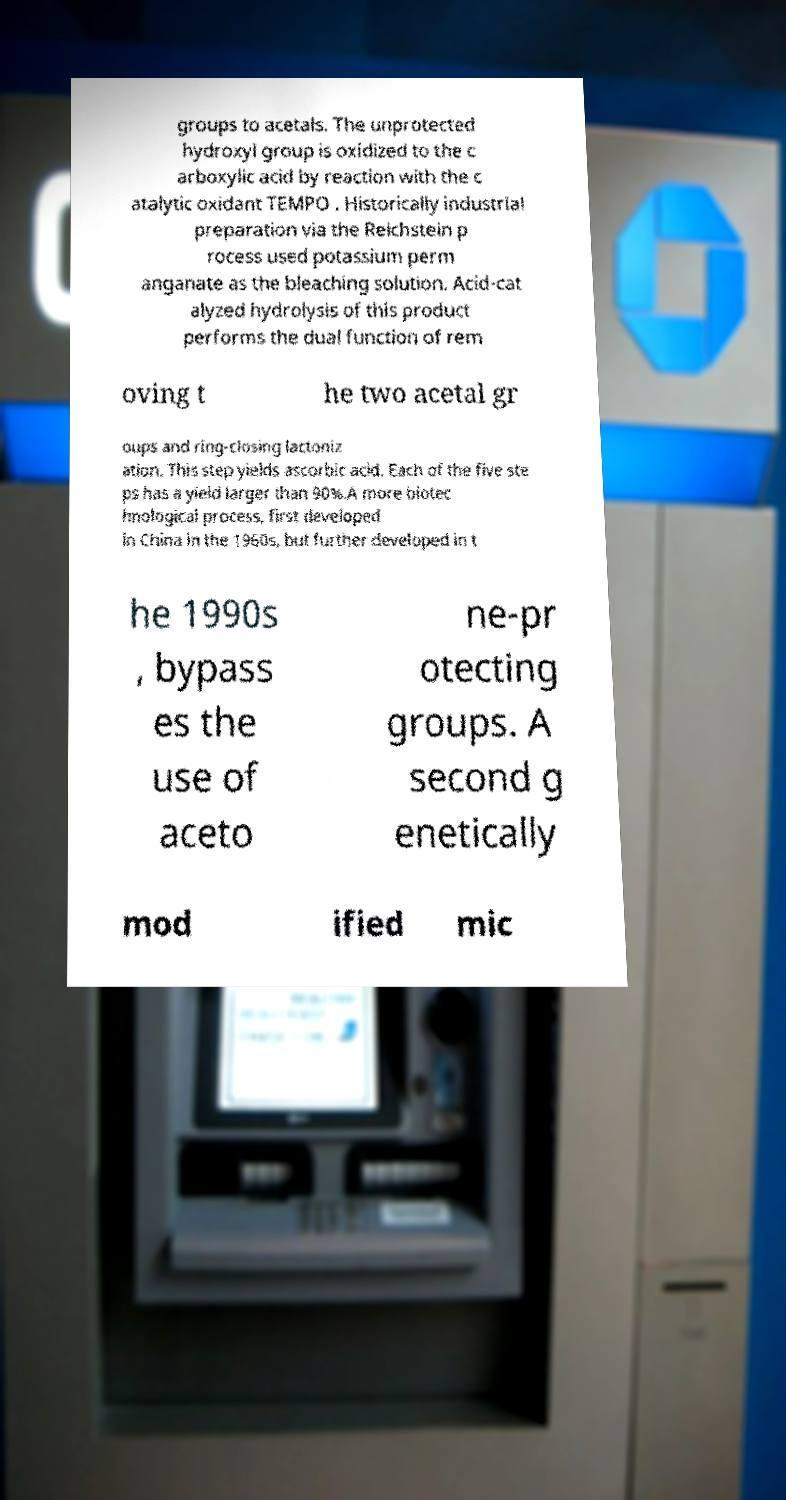Can you read and provide the text displayed in the image?This photo seems to have some interesting text. Can you extract and type it out for me? groups to acetals. The unprotected hydroxyl group is oxidized to the c arboxylic acid by reaction with the c atalytic oxidant TEMPO . Historically industrial preparation via the Reichstein p rocess used potassium perm anganate as the bleaching solution. Acid-cat alyzed hydrolysis of this product performs the dual function of rem oving t he two acetal gr oups and ring-closing lactoniz ation. This step yields ascorbic acid. Each of the five ste ps has a yield larger than 90%.A more biotec hnological process, first developed in China in the 1960s, but further developed in t he 1990s , bypass es the use of aceto ne-pr otecting groups. A second g enetically mod ified mic 